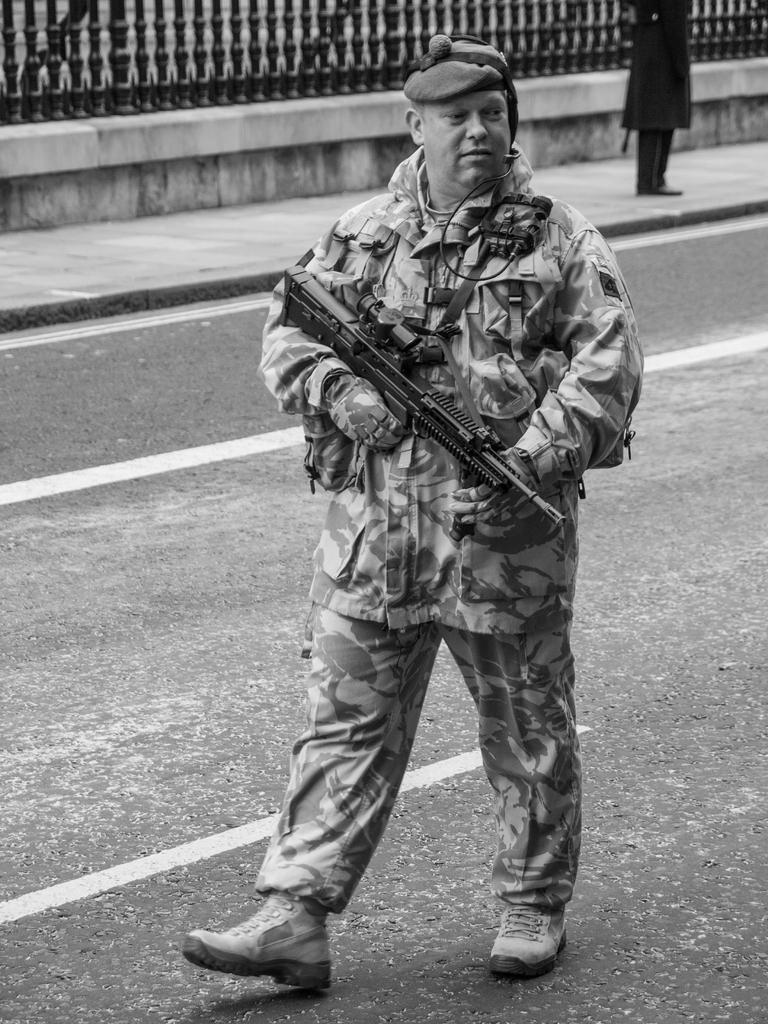Can you describe this image briefly? In this picture there is a cop in the center of the image, by holding a gun in his hand and there is another person and a boundary at the top side of the image. 